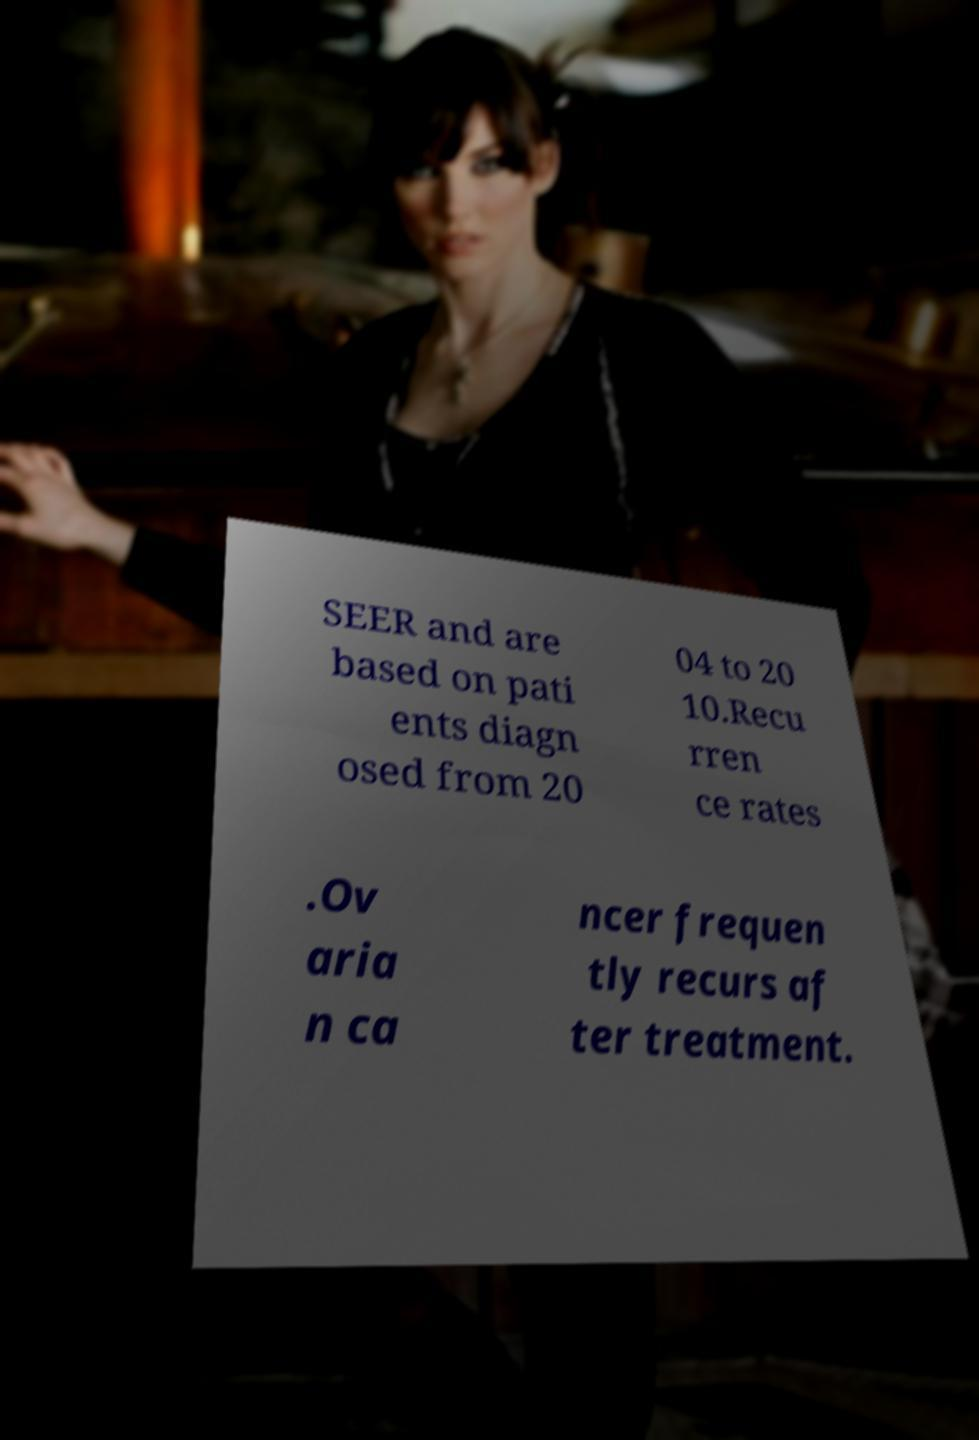I need the written content from this picture converted into text. Can you do that? SEER and are based on pati ents diagn osed from 20 04 to 20 10.Recu rren ce rates .Ov aria n ca ncer frequen tly recurs af ter treatment. 